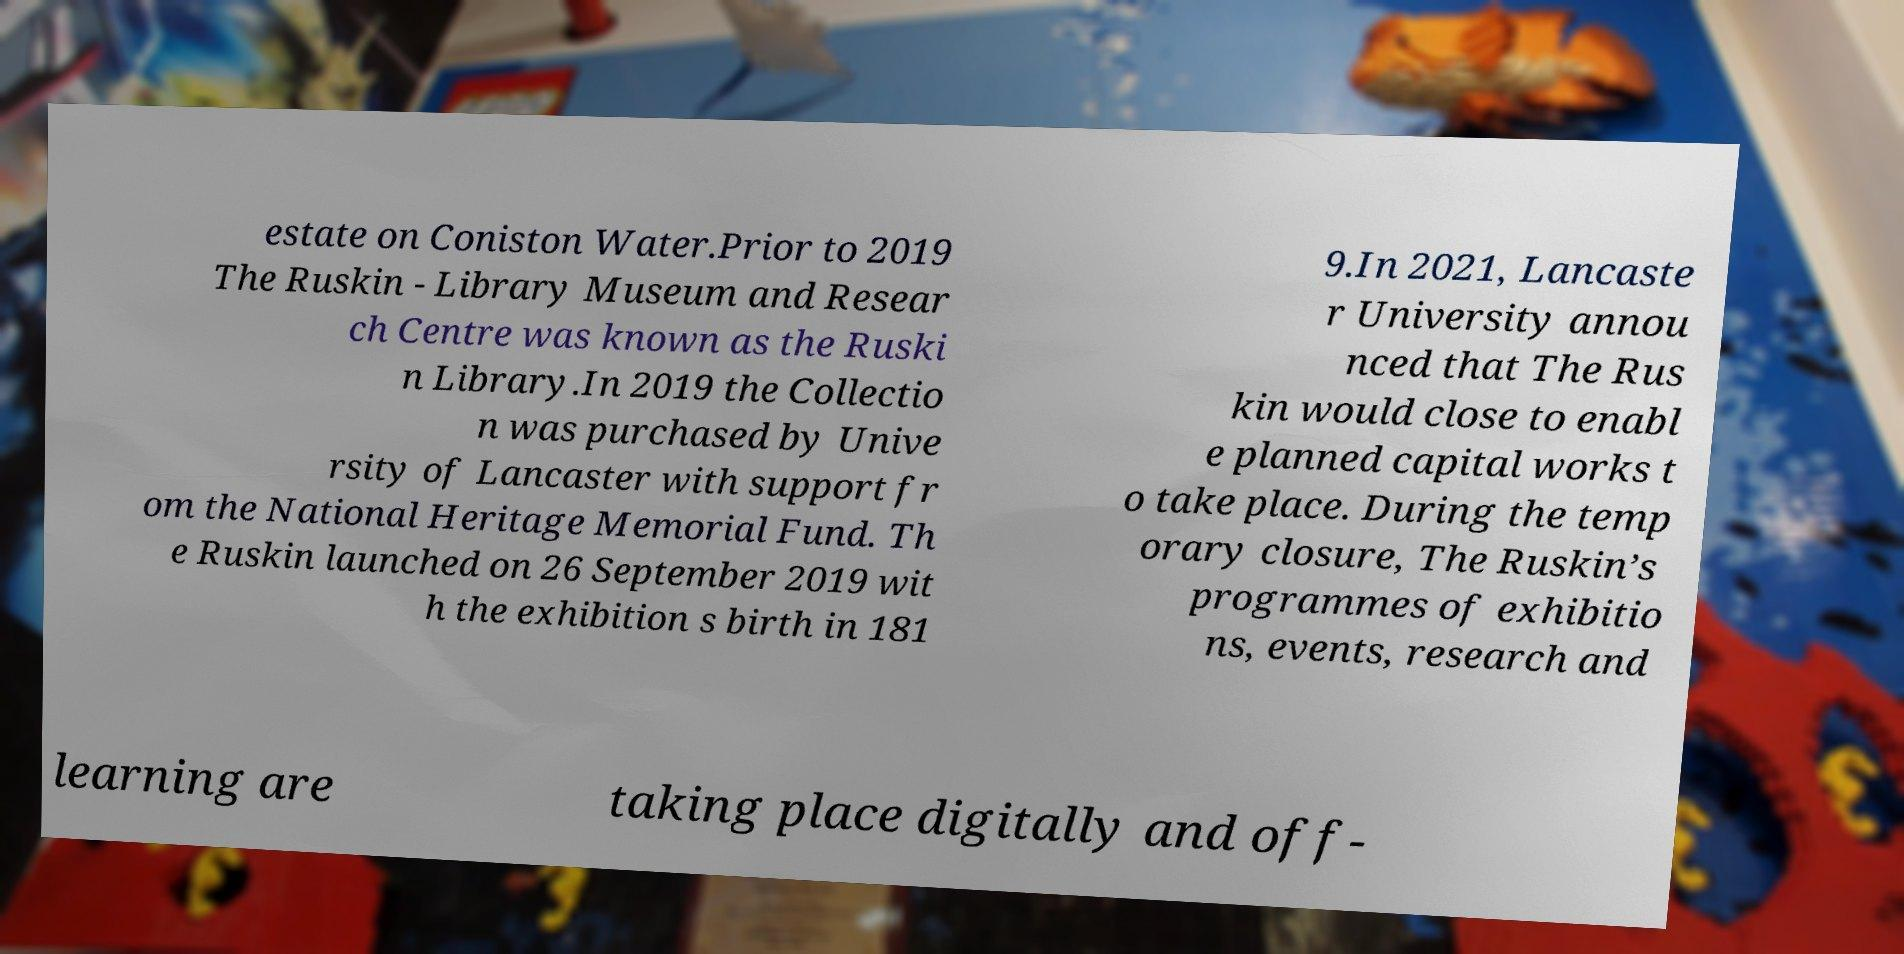Please read and relay the text visible in this image. What does it say? estate on Coniston Water.Prior to 2019 The Ruskin - Library Museum and Resear ch Centre was known as the Ruski n Library.In 2019 the Collectio n was purchased by Unive rsity of Lancaster with support fr om the National Heritage Memorial Fund. Th e Ruskin launched on 26 September 2019 wit h the exhibition s birth in 181 9.In 2021, Lancaste r University annou nced that The Rus kin would close to enabl e planned capital works t o take place. During the temp orary closure, The Ruskin’s programmes of exhibitio ns, events, research and learning are taking place digitally and off- 